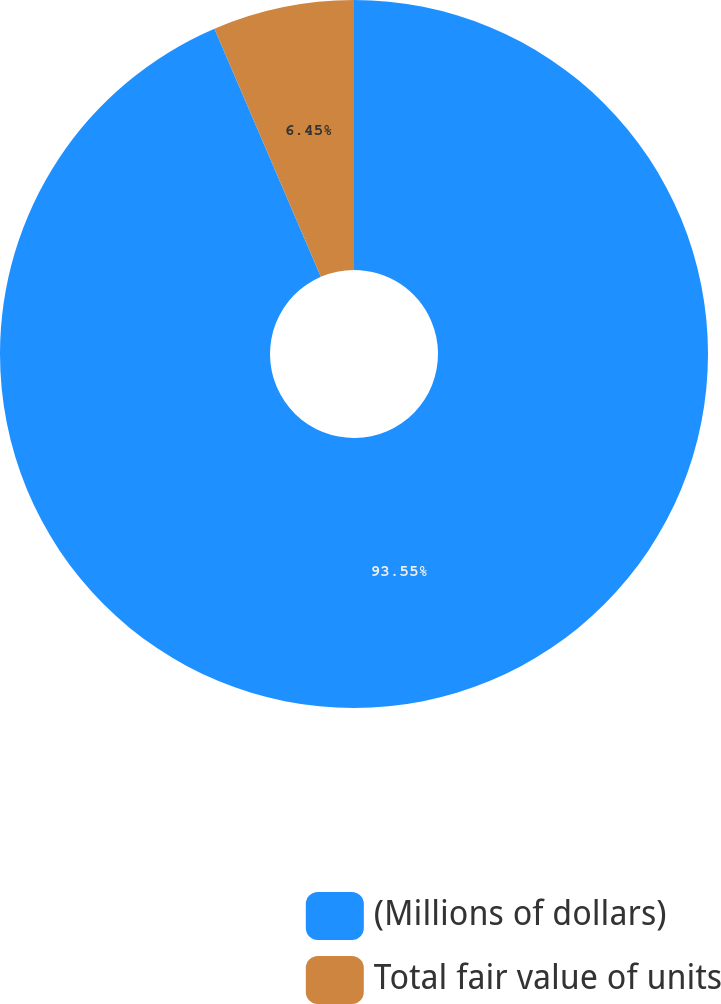<chart> <loc_0><loc_0><loc_500><loc_500><pie_chart><fcel>(Millions of dollars)<fcel>Total fair value of units<nl><fcel>93.55%<fcel>6.45%<nl></chart> 